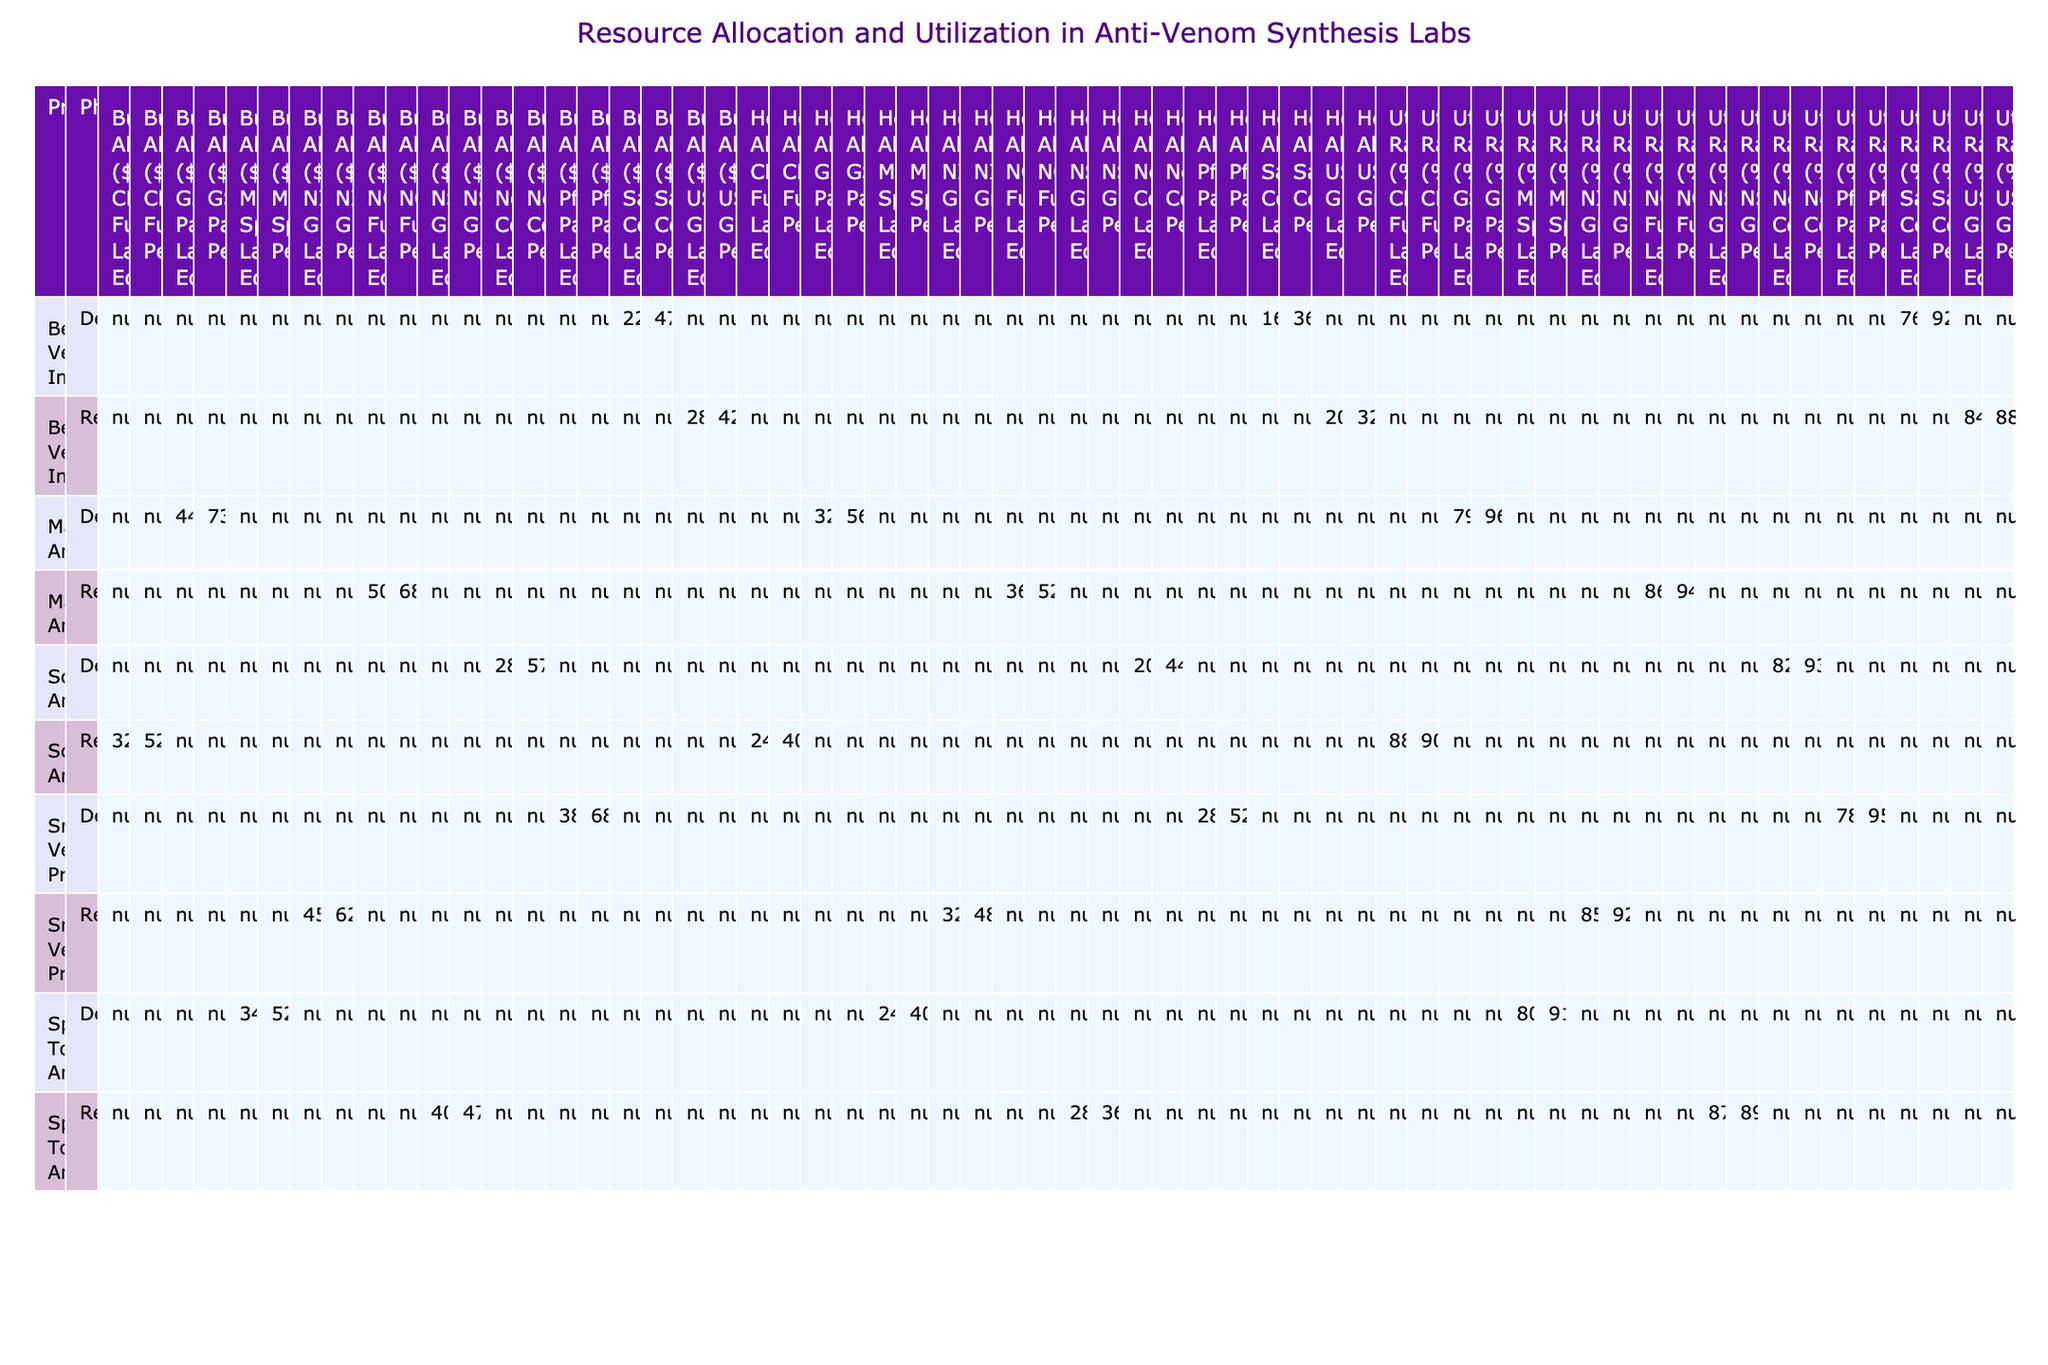What is the total budget allocated for the Scorpion Anti-venom in the Development phase? The Development phase for the Scorpion Anti-venom has funding from Novartis Collaboration. The budget allocated for Lab Equipment is $28,000 and for Personnel is $57,000. Therefore, the total budget is 28,000 + 57,000 = $85,000.
Answer: $85,000 What is the utilization rate for Snake Venom Proteomics in the Research phase? In the Research phase of Snake Venom Proteomics, we have a utilization rate of 85% for Lab Equipment and 92% for Personnel. Both of these are listed under the same phase, the answer is 85% (for Lab Equipment).
Answer: 85% Is the hours allocated for the Marine Anti-venom Development phase higher than the hours allocated for the Bee Venom Immunotherapy Development phase? For Marine Anti-venom in the Development phase, the hours allocated are 320 (Lab Equipment) and 560 (Personnel), totaling 880 hours. For Bee Venom Immunotherapy, the hours are 160 (Lab Equipment) and 360 (Personnel), totaling 520 hours. Since 880 is greater than 520, the answer is yes.
Answer: Yes What is the average utilization rate across all projects in the Research phase? First, we need to collect the utilization rates from all Research phases: for Snake Venom Proteomics (85% and 92%), Scorpion Anti-venom (88% and 90%), Spider Toxin Analysis (87% and 89%), and Marine Anti-venom (86% and 94%). This gives us: 85, 92, 88, 90, 87, 89, 86, 94. The total is 720, and the average is 720 divided by 8, which is 90%.
Answer: 90% Is the total budget allocated for personnel in the Development phase across all projects greater than $200,000? For the Development phase across the projects, we have the following personnel budgets: Snake Venom Proteomics $68,000, Scorpion Anti-venom $57,000, Spider Toxin Analysis $52,000, Marine Anti-venom $73,000, and Bee Venom Immunotherapy $47,000. Summing these values gives $68,000 + $57,000 + $52,000 + $73,000 + $47,000 = $297,000, which is greater than $200,000. Therefore, the answer is yes.
Answer: Yes 